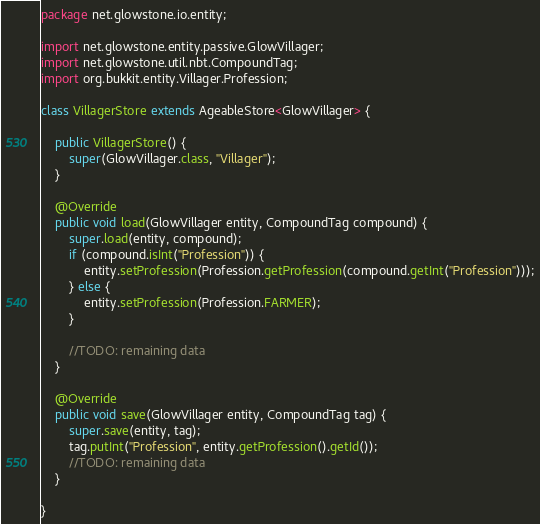Convert code to text. <code><loc_0><loc_0><loc_500><loc_500><_Java_>package net.glowstone.io.entity;

import net.glowstone.entity.passive.GlowVillager;
import net.glowstone.util.nbt.CompoundTag;
import org.bukkit.entity.Villager.Profession;

class VillagerStore extends AgeableStore<GlowVillager> {

    public VillagerStore() {
        super(GlowVillager.class, "Villager");
    }

    @Override
    public void load(GlowVillager entity, CompoundTag compound) {
        super.load(entity, compound);
        if (compound.isInt("Profession")) {
            entity.setProfession(Profession.getProfession(compound.getInt("Profession")));
        } else {
            entity.setProfession(Profession.FARMER);
        }

        //TODO: remaining data
    }

    @Override
    public void save(GlowVillager entity, CompoundTag tag) {
        super.save(entity, tag);
        tag.putInt("Profession", entity.getProfession().getId());
        //TODO: remaining data
    }

}
</code> 